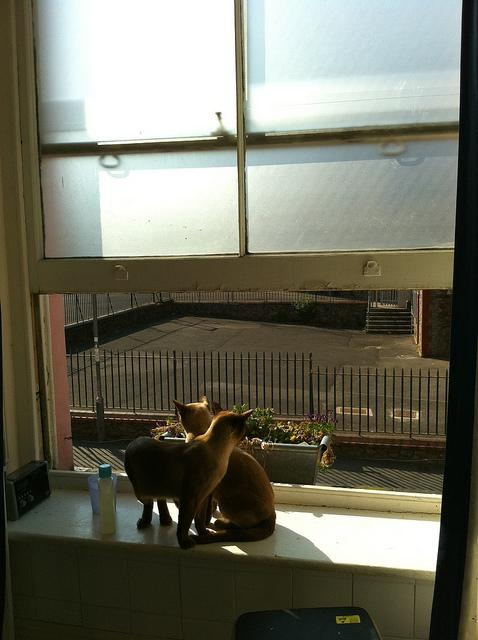How many Siamese cats are sitting atop the window cell? Please explain your reasoning. two. There are two siamese cats. they are sitting on the sill. 